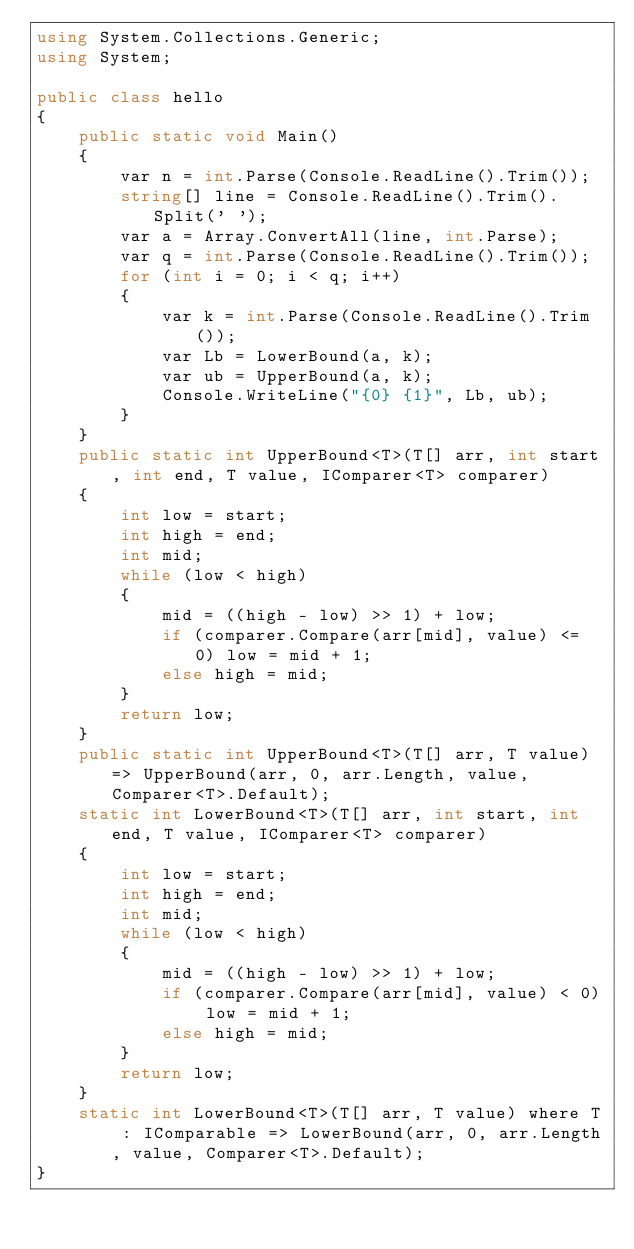<code> <loc_0><loc_0><loc_500><loc_500><_C#_>using System.Collections.Generic;
using System;

public class hello
{
    public static void Main()
    {
        var n = int.Parse(Console.ReadLine().Trim());
        string[] line = Console.ReadLine().Trim().Split(' ');
        var a = Array.ConvertAll(line, int.Parse);
        var q = int.Parse(Console.ReadLine().Trim());
        for (int i = 0; i < q; i++)
        {
            var k = int.Parse(Console.ReadLine().Trim());
            var Lb = LowerBound(a, k);
            var ub = UpperBound(a, k);
            Console.WriteLine("{0} {1}", Lb, ub);
        }
    }
    public static int UpperBound<T>(T[] arr, int start, int end, T value, IComparer<T> comparer)
    {
        int low = start;
        int high = end;
        int mid;
        while (low < high)
        {
            mid = ((high - low) >> 1) + low;
            if (comparer.Compare(arr[mid], value) <= 0) low = mid + 1;
            else high = mid;
        }
        return low;
    }
    public static int UpperBound<T>(T[] arr, T value) => UpperBound(arr, 0, arr.Length, value, Comparer<T>.Default);
    static int LowerBound<T>(T[] arr, int start, int end, T value, IComparer<T> comparer)
    {
        int low = start;
        int high = end;
        int mid;
        while (low < high)
        {
            mid = ((high - low) >> 1) + low;
            if (comparer.Compare(arr[mid], value) < 0) low = mid + 1;
            else high = mid;
        }
        return low;
    }
    static int LowerBound<T>(T[] arr, T value) where T : IComparable => LowerBound(arr, 0, arr.Length, value, Comparer<T>.Default);
}


</code> 